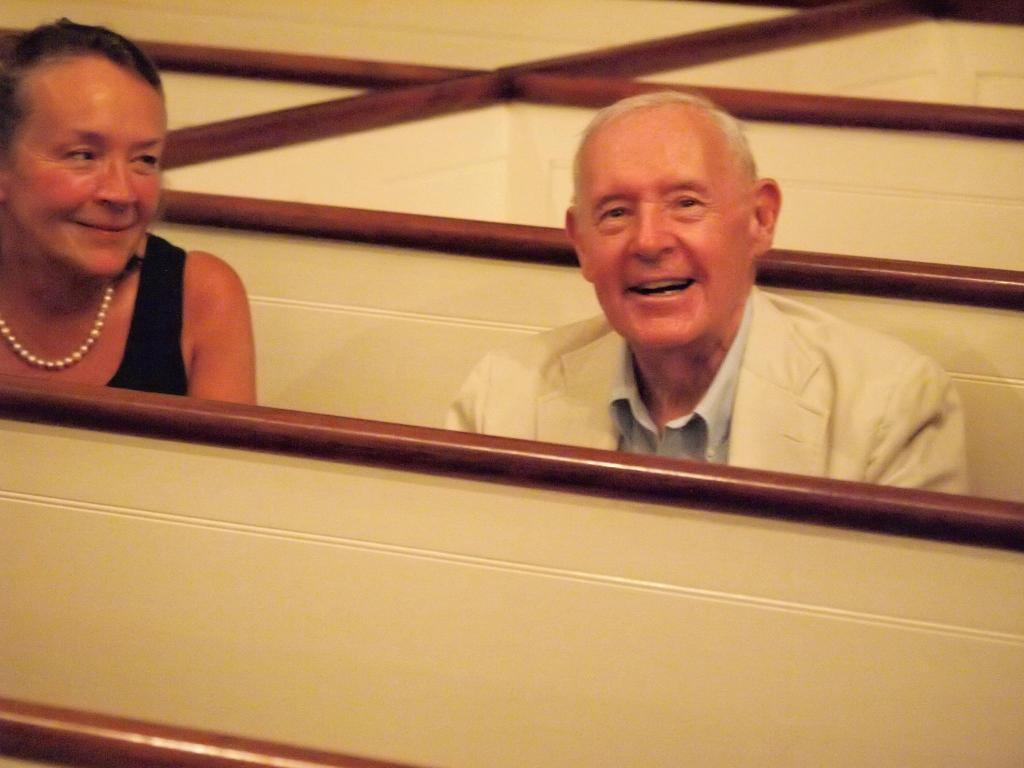In one or two sentences, can you explain what this image depicts? In this image we can see a man and a woman and at the bottom there is a wooden object. In the background we can see wooden objects. 